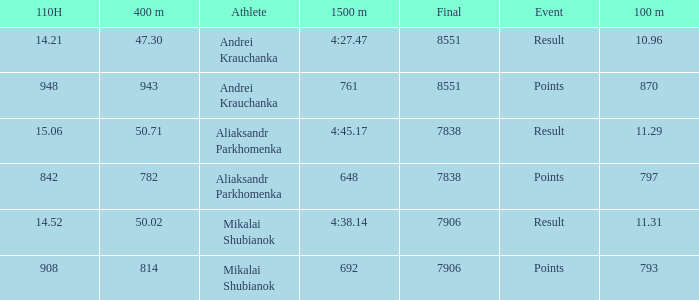What was the 110H that the 1500m was 692 and the final was more than 7906? 0.0. 